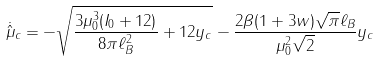<formula> <loc_0><loc_0><loc_500><loc_500>\dot { \hat { \mu } } _ { c } = - \sqrt { \frac { 3 \mu _ { 0 } ^ { 3 } ( I _ { 0 } + 1 2 ) } { 8 \pi \ell _ { B } ^ { 2 } } + 1 2 y _ { c } } - \frac { 2 \beta ( 1 + 3 w ) \sqrt { \pi } \ell _ { B } } { \mu _ { 0 } ^ { 2 } \sqrt { 2 } } y _ { c }</formula> 